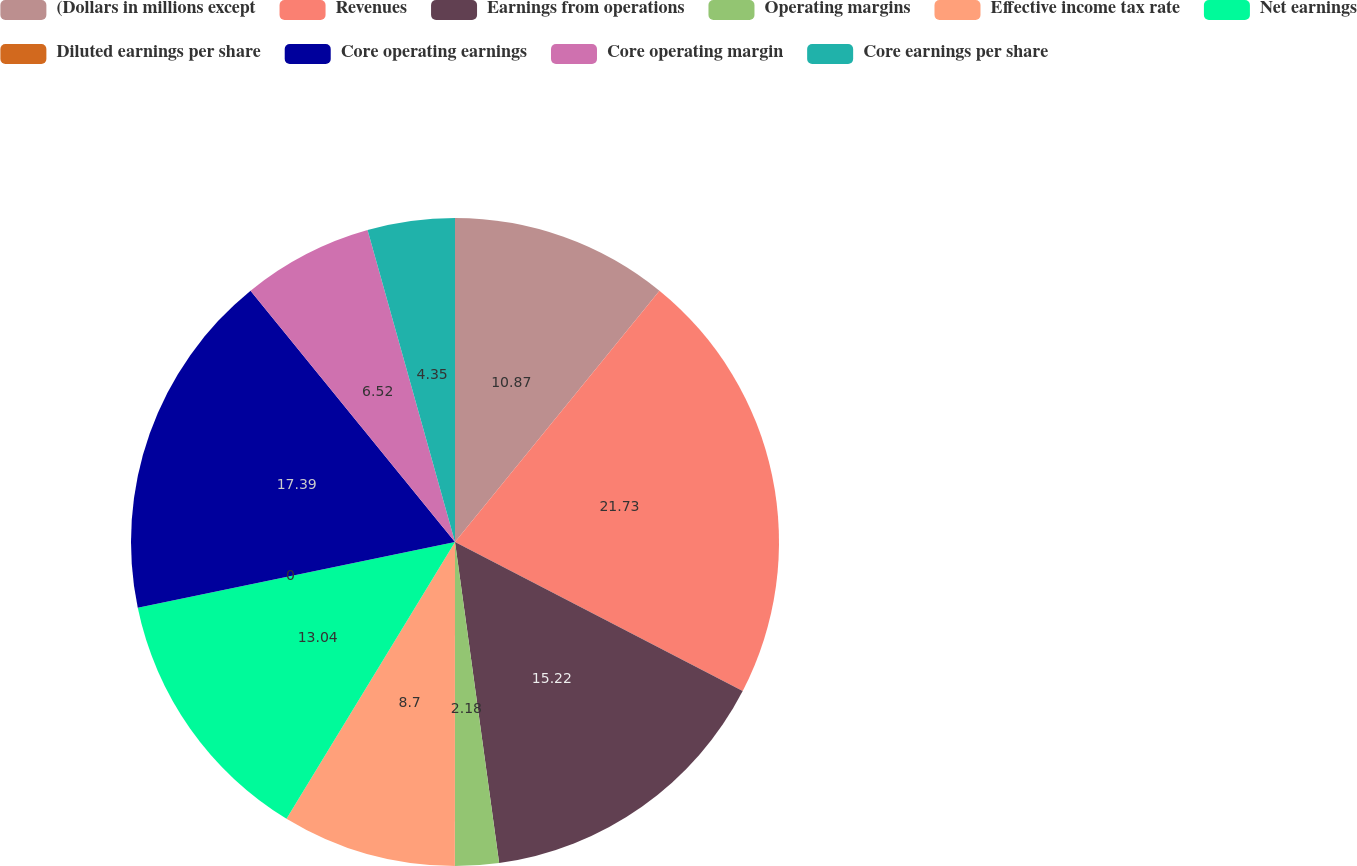<chart> <loc_0><loc_0><loc_500><loc_500><pie_chart><fcel>(Dollars in millions except<fcel>Revenues<fcel>Earnings from operations<fcel>Operating margins<fcel>Effective income tax rate<fcel>Net earnings<fcel>Diluted earnings per share<fcel>Core operating earnings<fcel>Core operating margin<fcel>Core earnings per share<nl><fcel>10.87%<fcel>21.74%<fcel>15.22%<fcel>2.18%<fcel>8.7%<fcel>13.04%<fcel>0.0%<fcel>17.39%<fcel>6.52%<fcel>4.35%<nl></chart> 